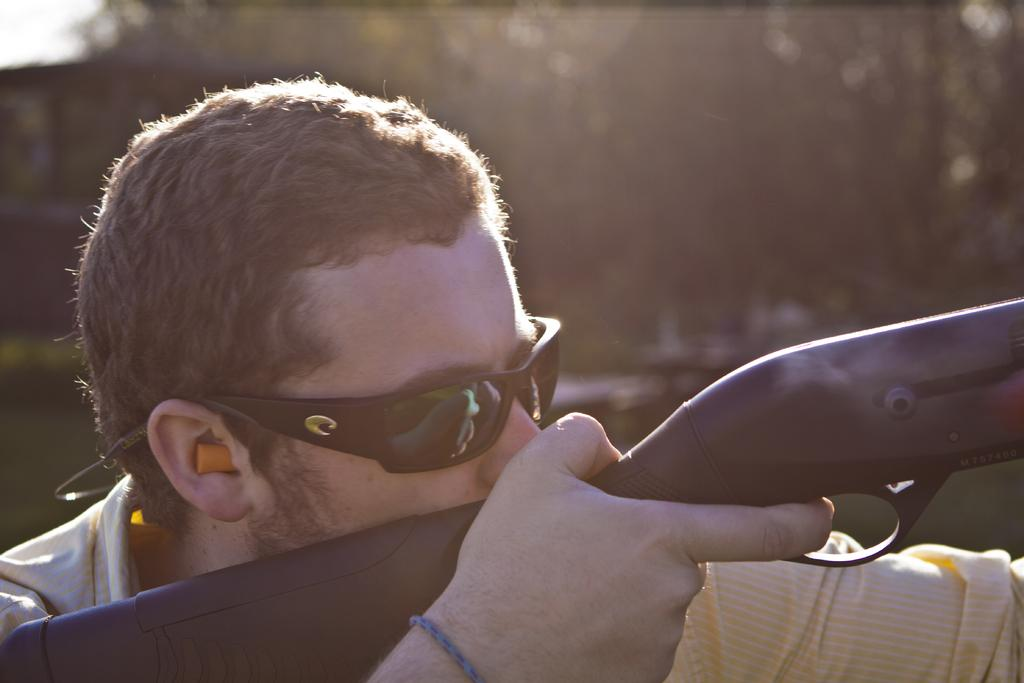Who is present in the image? There is a man in the image. What is the man holding in the image? The man is holding a gun. What protective gear is the man wearing? The man is wearing goggles. Can you describe the background of the image? The background of the image is blurred. What type of bag is the man carrying in the image? There is no bag present in the image. What type of cap is the man wearing in the image? There is no cap present in the image. 